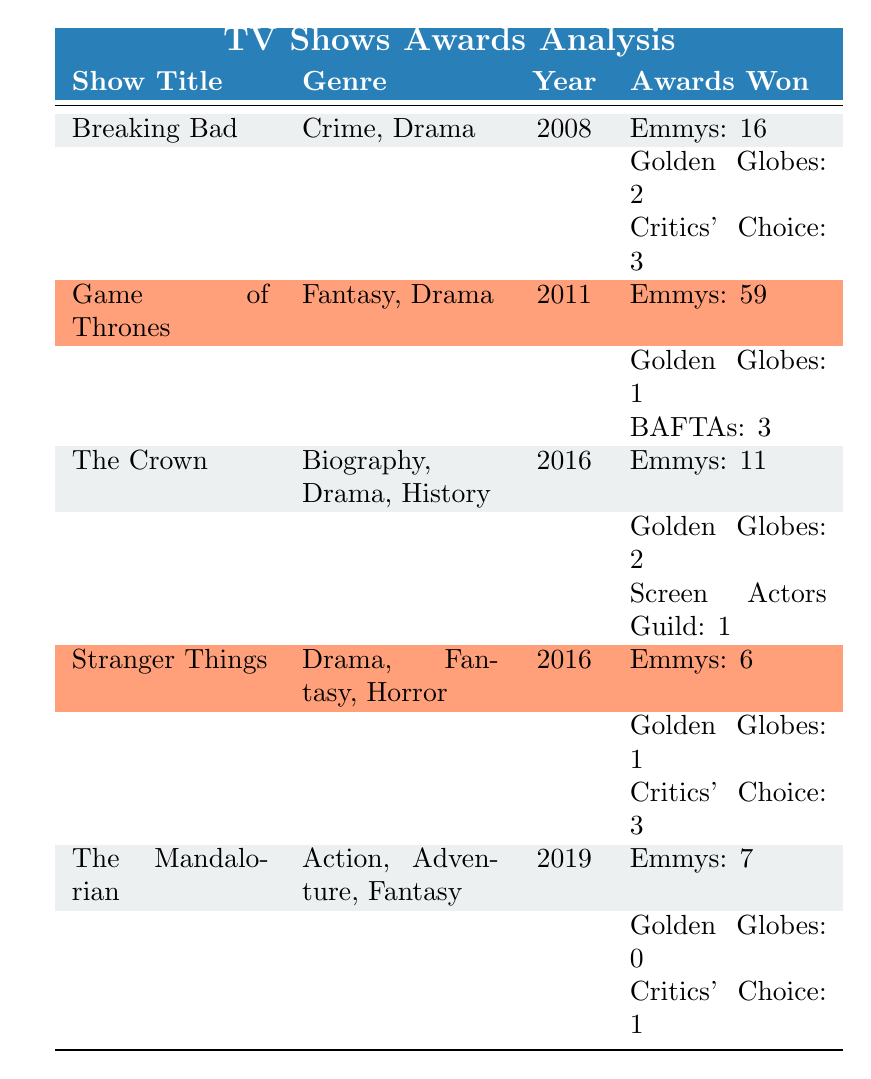What is the genre of "Stranger Things"? The table lists the genre of each TV show in the genre column. For "Stranger Things", it shows "Drama, Fantasy, Horror".
Answer: Drama, Fantasy, Horror How many Emmys did "Game of Thrones" win? Looking at the awards won by "Game of Thrones", the table shows it won 59 Emmys.
Answer: 59 Which show won the most awards? By comparing the total number of awards won by each show, we can sum the individual award counts. "Game of Thrones" won 59 Emmys, 1 Golden Globe, and 3 BAFTAs, totaling 63 awards. This is greater than any other show listed.
Answer: Game of Thrones Did "The Mandalorian" win any Golden Globes? The table specifies that "The Mandalorian" won 0 Golden Globes.
Answer: No What is the total number of awards won by "The Crown" and "Stranger Things"? We need to sum the total awards for both shows. "The Crown" has 11 Emmys, 2 Golden Globes, and 1 Screen Actors Guild (total of 14), while "Stranger Things" has 6 Emmys, 1 Golden Globe, and 3 Critics' Choice (total of 10). Adding these gives 14 + 10 = 24.
Answer: 24 How many shows won more than 10 Emmys? We review the Emmys won by each show. "Breaking Bad" has 16, "Game of Thrones" 59, and "The Crown" 11 all above 10. This gives us a total of 3 shows that won more than 10 Emmys.
Answer: 3 What is the average number of Golden Globes won by the shows listed? We sum the Golden Globes won: 2 (Breaking Bad) + 1 (Game of Thrones) + 2 (The Crown) + 1 (Stranger Things) + 0 (The Mandalorian) = 6. There are 5 shows, so the average is 6 / 5 = 1.2.
Answer: 1.2 Which show won the fewest awards overall? To determine this, we sum the awards won by each show. Breaking Bad has 21 total awards, Game of Thrones 63, The Crown 14, Stranger Things 10, and The Mandalorian 8. "The Mandalorian" has the fewest with 8 awards.
Answer: The Mandalorian Does "Stranger Things" and "The Crown" have any awards in common? The awards won by "Stranger Things" include Emmys, Golden Globes, and Critics' Choice. "The Crown" won Emmys and Golden Globes. Both shows won Golden Globes and Emmys, making the answer yes.
Answer: Yes 